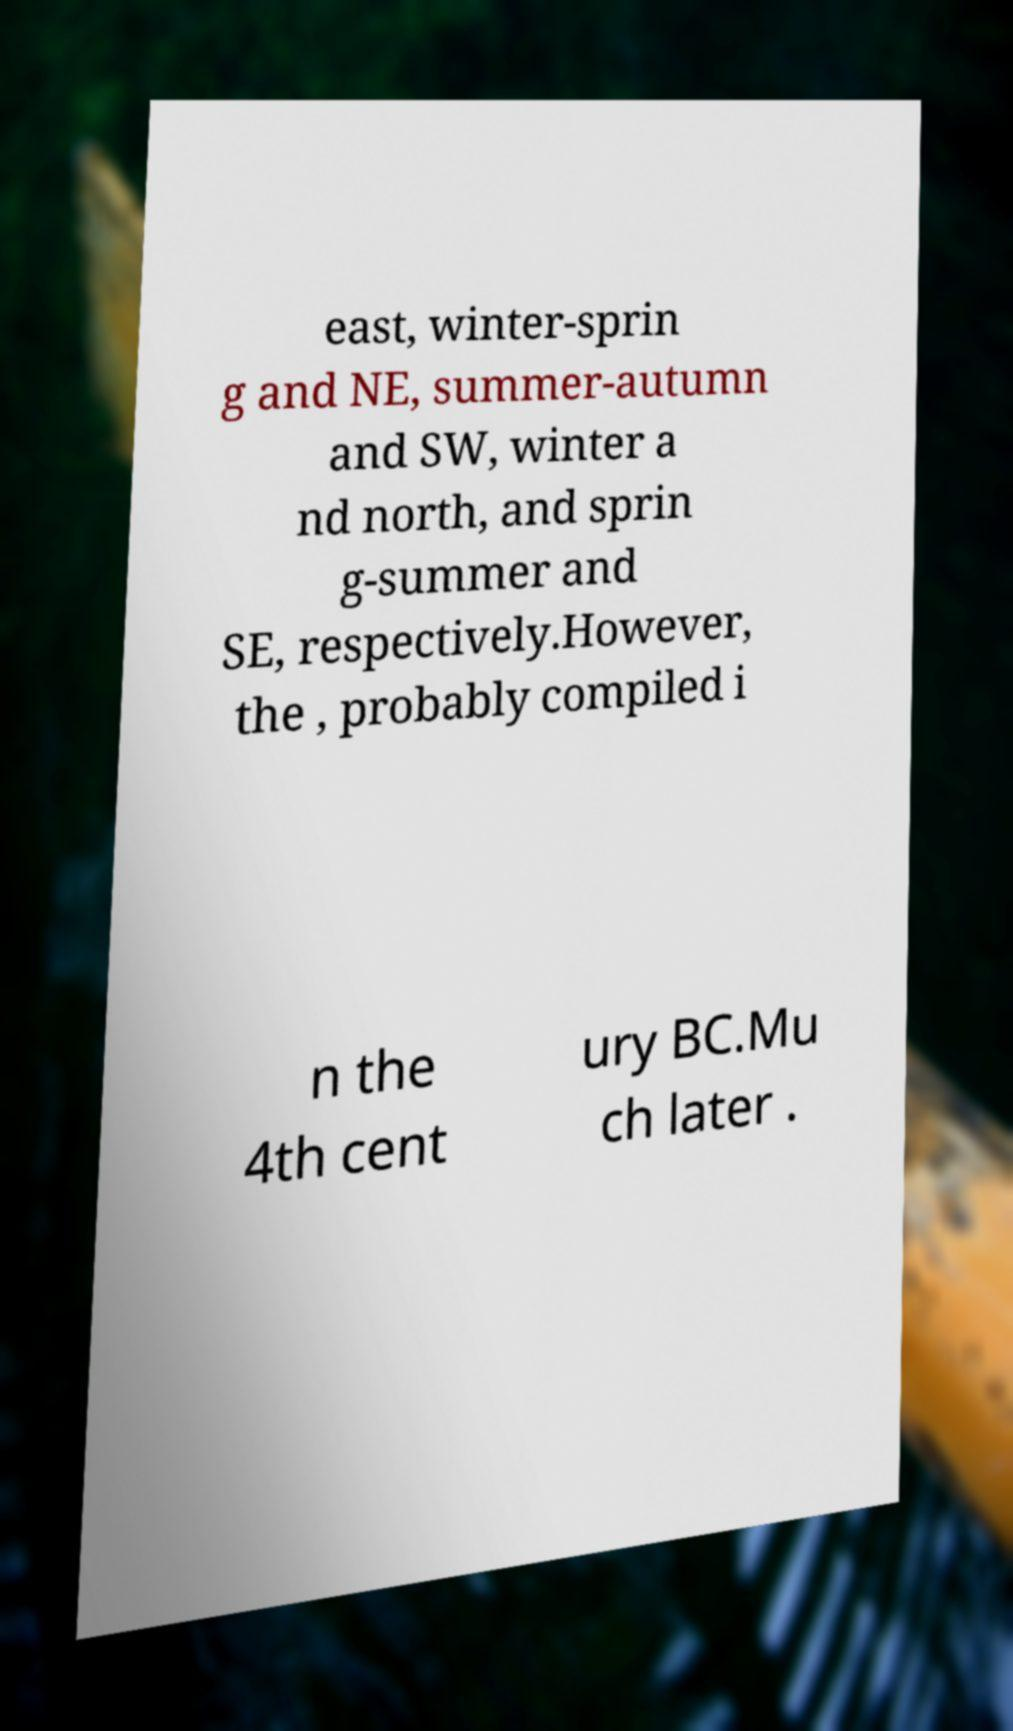Could you extract and type out the text from this image? east, winter-sprin g and NE, summer-autumn and SW, winter a nd north, and sprin g-summer and SE, respectively.However, the , probably compiled i n the 4th cent ury BC.Mu ch later . 